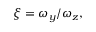<formula> <loc_0><loc_0><loc_500><loc_500>\xi = \omega _ { y } / \omega _ { z } ,</formula> 